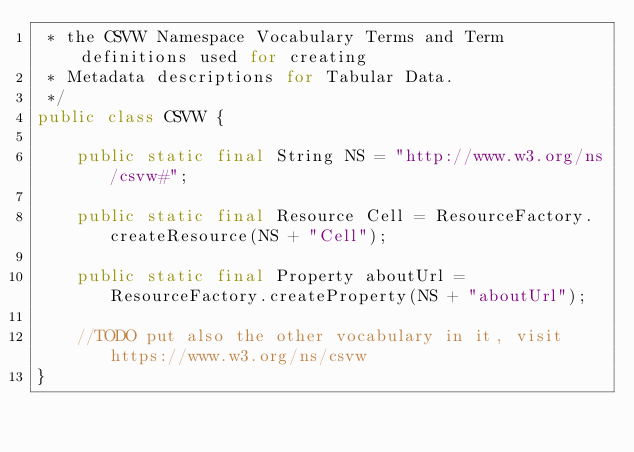<code> <loc_0><loc_0><loc_500><loc_500><_Java_> * the CSVW Namespace Vocabulary Terms and Term definitions used for creating 
 * Metadata descriptions for Tabular Data.
 */
public class CSVW {

    public static final String NS = "http://www.w3.org/ns/csvw#";
    
    public static final Resource Cell = ResourceFactory.createResource(NS + "Cell");
    
    public static final Property aboutUrl = ResourceFactory.createProperty(NS + "aboutUrl");
    
    //TODO put also the other vocabulary in it, visit https://www.w3.org/ns/csvw
}
</code> 